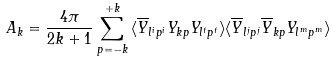<formula> <loc_0><loc_0><loc_500><loc_500>A _ { k } = \frac { 4 \pi } { 2 k + 1 } \sum _ { p = - k } ^ { + k } { \langle \overline { Y } _ { l ^ { i } p ^ { i } } Y _ { k p } Y _ { l ^ { t } p ^ { t } } \rangle \langle \overline { Y } _ { l ^ { j } p ^ { j } } \overline { Y } _ { k p } Y _ { l ^ { m } p ^ { m } } \rangle }</formula> 